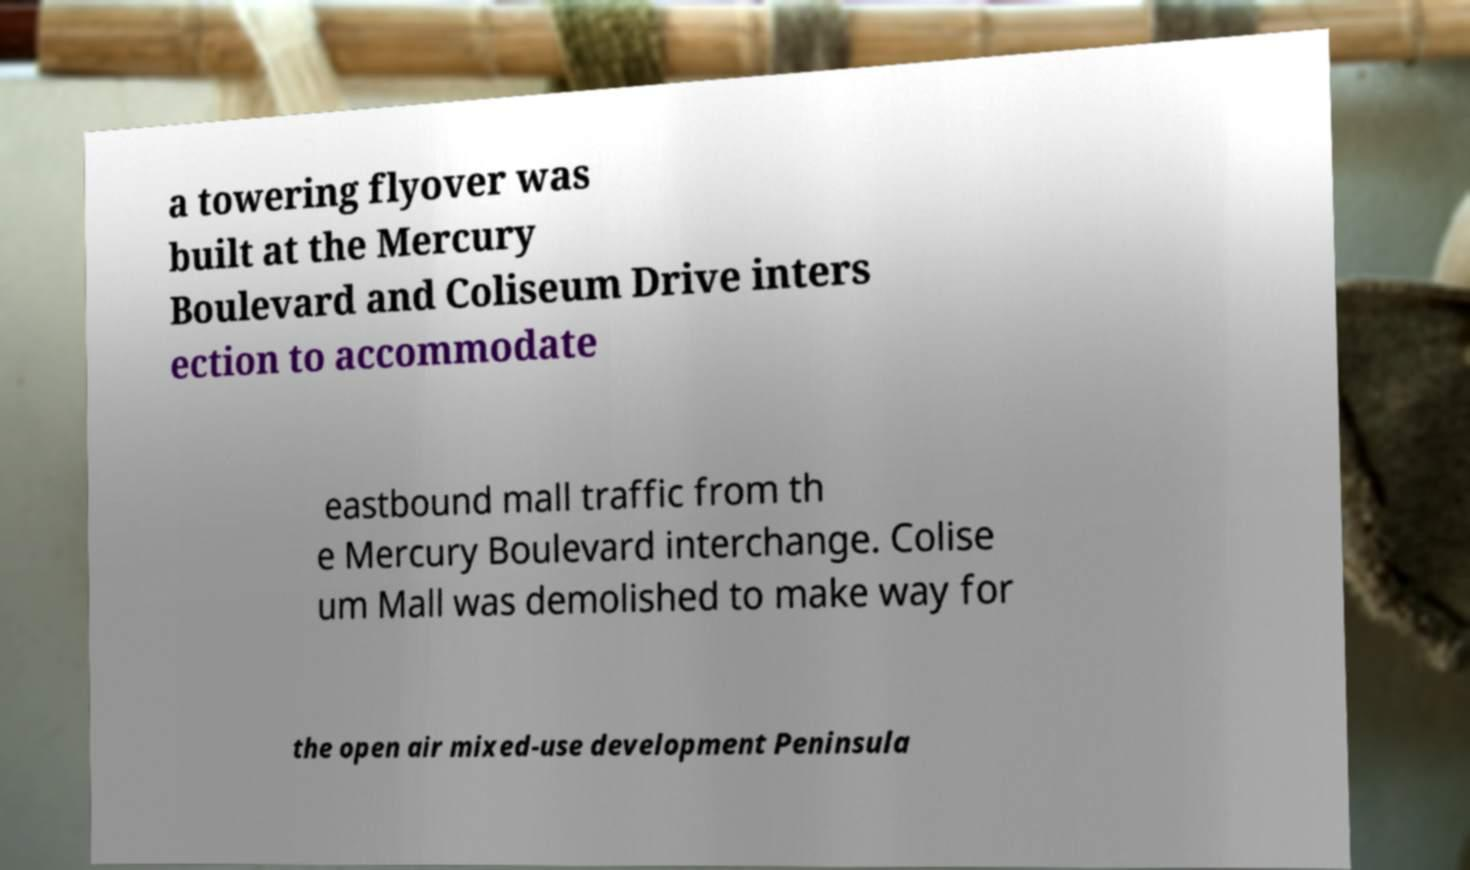Please read and relay the text visible in this image. What does it say? a towering flyover was built at the Mercury Boulevard and Coliseum Drive inters ection to accommodate eastbound mall traffic from th e Mercury Boulevard interchange. Colise um Mall was demolished to make way for the open air mixed-use development Peninsula 